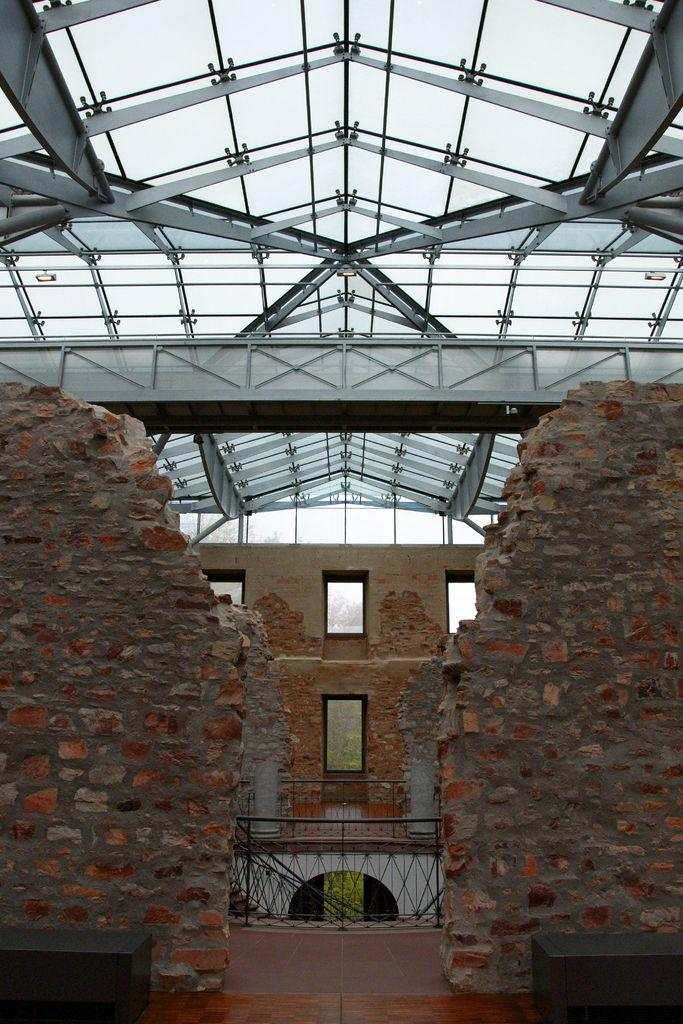What type of structure is in the image? There is a building in the image. What can be seen at the top of the building? Metal rods are visible at the top of the building. What type of barrier is present in the image? There is a fence in the image. What other architectural feature can be seen in the image? There is a wall in the image. What is visible in the background of the image? Trees and the sky are visible in the background of the image. Can you see a yak grazing near the building in the image? There is no yak present in the image. 